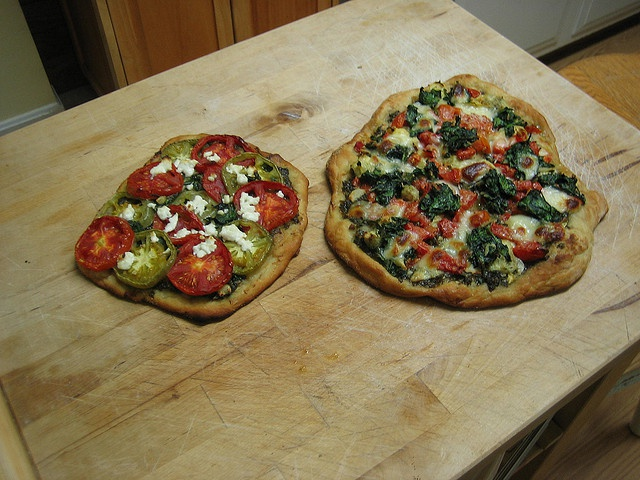Describe the objects in this image and their specific colors. I can see dining table in tan, darkgreen, olive, and black tones, pizza in darkgreen, black, and olive tones, and pizza in darkgreen, maroon, olive, and black tones in this image. 